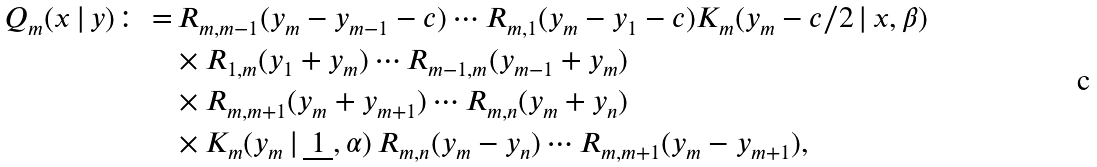<formula> <loc_0><loc_0><loc_500><loc_500>Q _ { m } ( x \, | \, y ) \colon = & \, R _ { m , m - 1 } ( y _ { m } - y _ { m - 1 } - c ) \cdots R _ { m , 1 } ( y _ { m } - y _ { 1 } - c ) K _ { m } ( y _ { m } - c / 2 \, | \, x , \beta ) \\ & \times R _ { 1 , m } ( y _ { 1 } + y _ { m } ) \cdots R _ { m - 1 , m } ( y _ { m - 1 } + y _ { m } ) \\ & \times R _ { m , m + 1 } ( y _ { m } + y _ { m + 1 } ) \cdots R _ { m , n } ( y _ { m } + y _ { n } ) \\ & \times K _ { m } ( y _ { m } \, | \, \underbar { $ 1 $ } , \alpha ) \, R _ { m , n } ( y _ { m } - y _ { n } ) \cdots R _ { m , m + 1 } ( y _ { m } - y _ { m + 1 } ) ,</formula> 